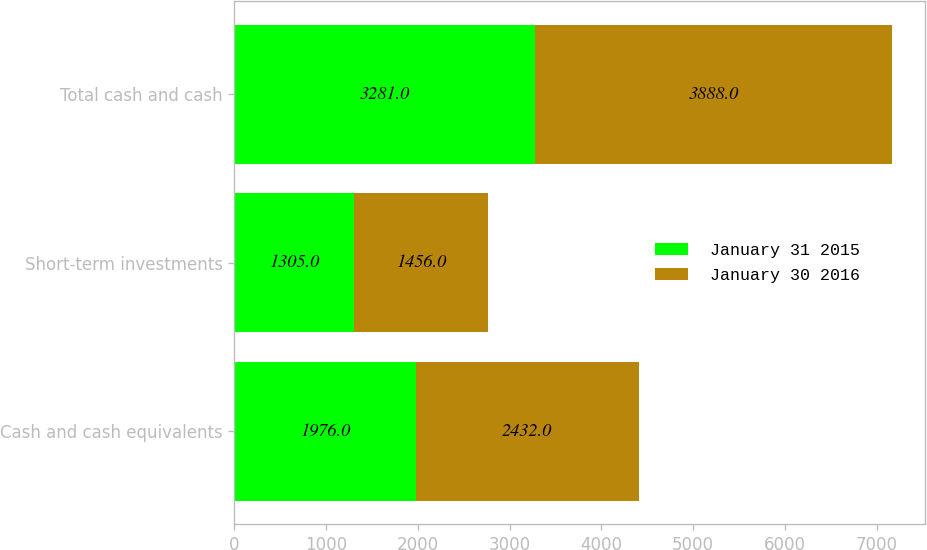Convert chart to OTSL. <chart><loc_0><loc_0><loc_500><loc_500><stacked_bar_chart><ecel><fcel>Cash and cash equivalents<fcel>Short-term investments<fcel>Total cash and cash<nl><fcel>January 31 2015<fcel>1976<fcel>1305<fcel>3281<nl><fcel>January 30 2016<fcel>2432<fcel>1456<fcel>3888<nl></chart> 